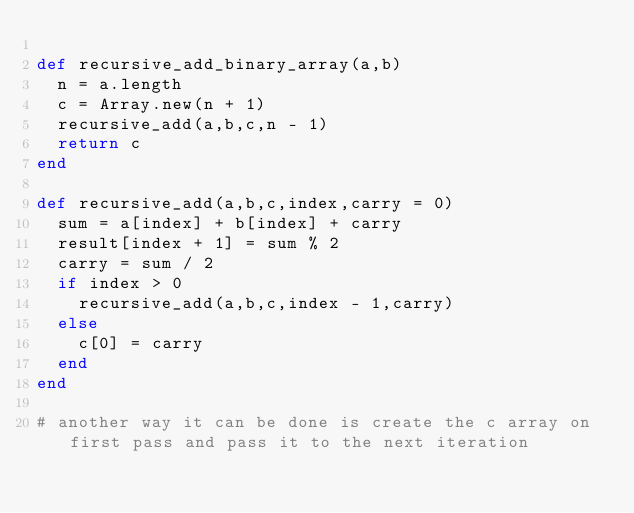Convert code to text. <code><loc_0><loc_0><loc_500><loc_500><_Ruby_>
def recursive_add_binary_array(a,b)
  n = a.length
  c = Array.new(n + 1)
  recursive_add(a,b,c,n - 1)
  return c
end

def recursive_add(a,b,c,index,carry = 0)
  sum = a[index] + b[index] + carry
  result[index + 1] = sum % 2
  carry = sum / 2
  if index > 0
    recursive_add(a,b,c,index - 1,carry)
  else
    c[0] = carry
  end
end

# another way it can be done is create the c array on first pass and pass it to the next iteration</code> 